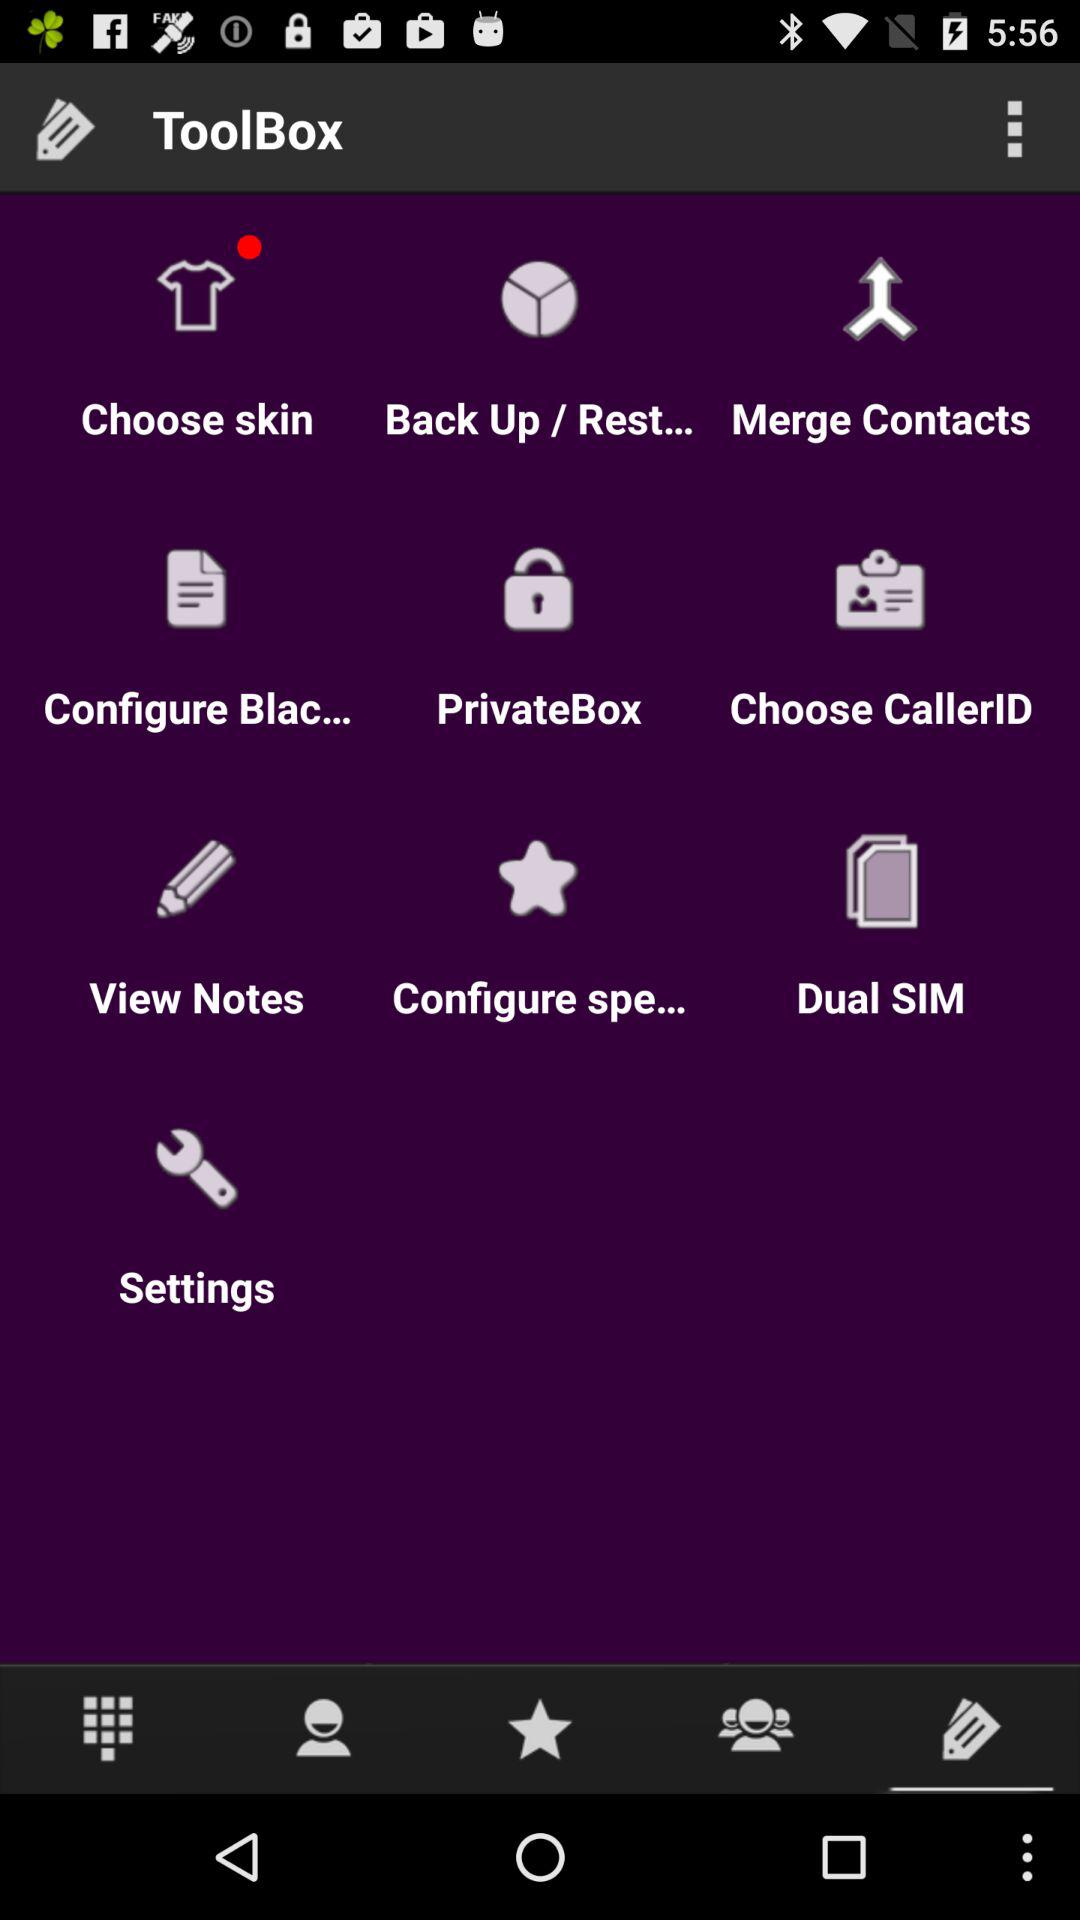Does the user have a dual SIM?
When the provided information is insufficient, respond with <no answer>. <no answer> 